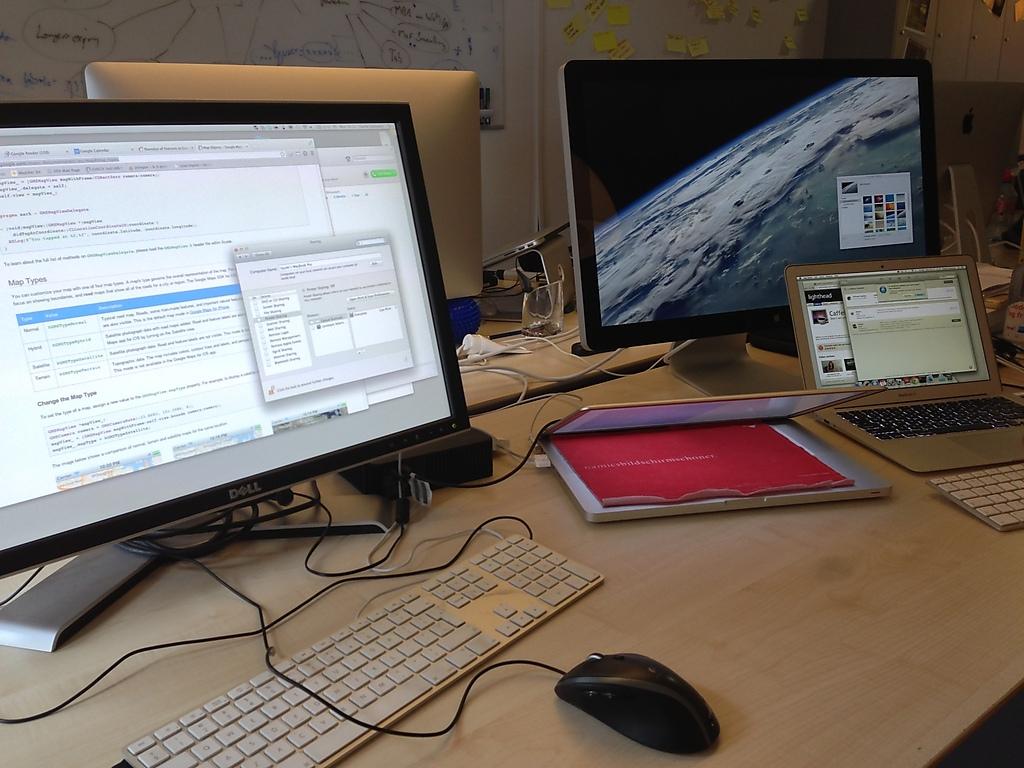What is the brand of monitor?
Provide a succinct answer. Dell. 